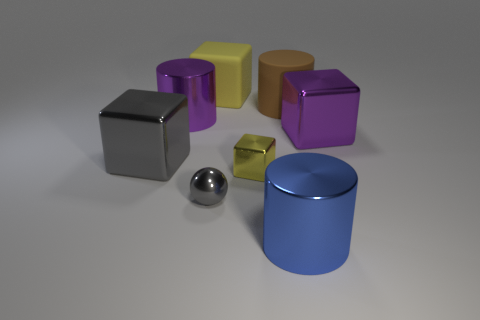Subtract all gray metal cubes. How many cubes are left? 3 Subtract all yellow blocks. How many blocks are left? 2 Subtract 4 cubes. How many cubes are left? 0 Add 2 cylinders. How many objects exist? 10 Subtract all red cylinders. How many yellow blocks are left? 2 Add 8 gray metal things. How many gray metal things are left? 10 Add 4 large purple cylinders. How many large purple cylinders exist? 5 Subtract 0 red cylinders. How many objects are left? 8 Subtract all cylinders. How many objects are left? 5 Subtract all purple cylinders. Subtract all cyan blocks. How many cylinders are left? 2 